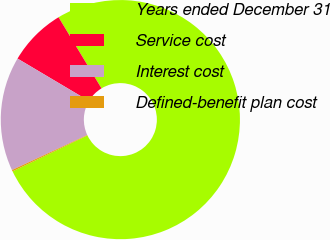<chart> <loc_0><loc_0><loc_500><loc_500><pie_chart><fcel>Years ended December 31<fcel>Service cost<fcel>Interest cost<fcel>Defined-benefit plan cost<nl><fcel>76.52%<fcel>7.83%<fcel>15.46%<fcel>0.19%<nl></chart> 